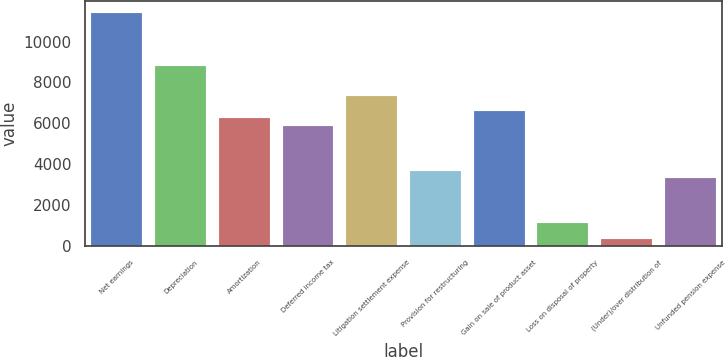<chart> <loc_0><loc_0><loc_500><loc_500><bar_chart><fcel>Net earnings<fcel>Depreciation<fcel>Amortization<fcel>Deferred income tax<fcel>Litigation settlement expense<fcel>Provision for restructuring<fcel>Gain on sale of product asset<fcel>Loss on disposal of property<fcel>(Under)/over distribution of<fcel>Unfunded pension expense<nl><fcel>11401.7<fcel>8827.8<fcel>6253.9<fcel>5886.2<fcel>7357<fcel>3680<fcel>6621.6<fcel>1106.1<fcel>370.7<fcel>3312.3<nl></chart> 